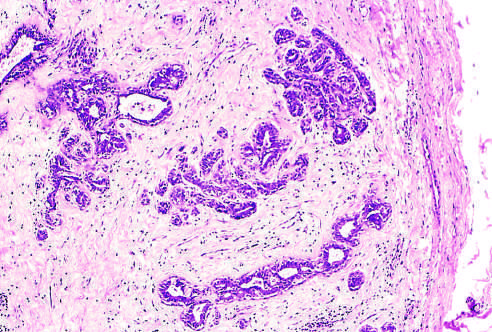what delimits the tumor from the surrounding tissue?
Answer the question using a single word or phrase. The fibrous capsule 